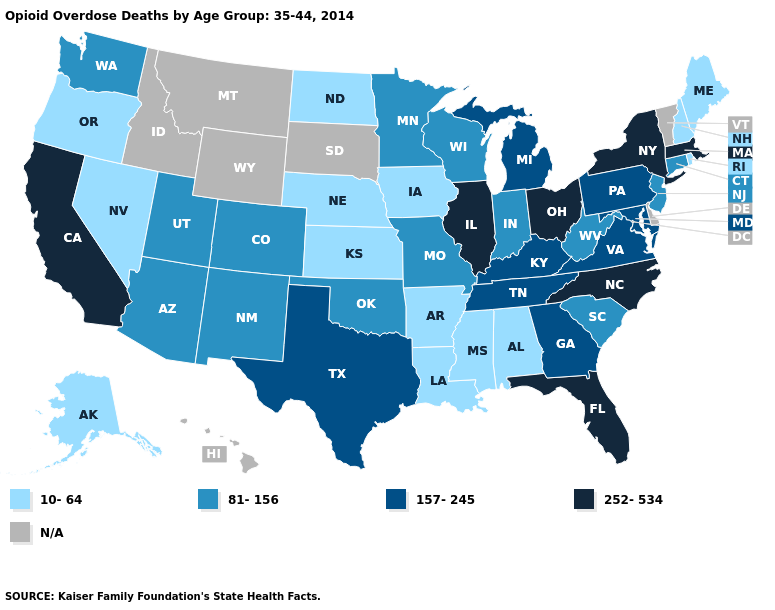Which states have the highest value in the USA?
Be succinct. California, Florida, Illinois, Massachusetts, New York, North Carolina, Ohio. Among the states that border Idaho , does Washington have the highest value?
Be succinct. Yes. Name the states that have a value in the range N/A?
Write a very short answer. Delaware, Hawaii, Idaho, Montana, South Dakota, Vermont, Wyoming. Which states have the highest value in the USA?
Write a very short answer. California, Florida, Illinois, Massachusetts, New York, North Carolina, Ohio. Which states have the highest value in the USA?
Quick response, please. California, Florida, Illinois, Massachusetts, New York, North Carolina, Ohio. Name the states that have a value in the range N/A?
Write a very short answer. Delaware, Hawaii, Idaho, Montana, South Dakota, Vermont, Wyoming. What is the lowest value in the West?
Give a very brief answer. 10-64. Among the states that border Georgia , which have the lowest value?
Write a very short answer. Alabama. Name the states that have a value in the range 157-245?
Keep it brief. Georgia, Kentucky, Maryland, Michigan, Pennsylvania, Tennessee, Texas, Virginia. What is the value of Idaho?
Write a very short answer. N/A. What is the value of New York?
Short answer required. 252-534. Name the states that have a value in the range 10-64?
Concise answer only. Alabama, Alaska, Arkansas, Iowa, Kansas, Louisiana, Maine, Mississippi, Nebraska, Nevada, New Hampshire, North Dakota, Oregon, Rhode Island. Which states have the lowest value in the MidWest?
Be succinct. Iowa, Kansas, Nebraska, North Dakota. What is the value of New York?
Concise answer only. 252-534. 